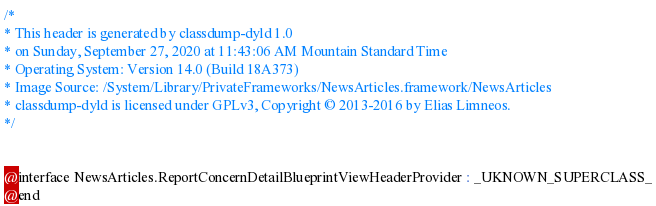Convert code to text. <code><loc_0><loc_0><loc_500><loc_500><_C_>/*
* This header is generated by classdump-dyld 1.0
* on Sunday, September 27, 2020 at 11:43:06 AM Mountain Standard Time
* Operating System: Version 14.0 (Build 18A373)
* Image Source: /System/Library/PrivateFrameworks/NewsArticles.framework/NewsArticles
* classdump-dyld is licensed under GPLv3, Copyright © 2013-2016 by Elias Limneos.
*/


@interface NewsArticles.ReportConcernDetailBlueprintViewHeaderProvider : _UKNOWN_SUPERCLASS_
@end

</code> 